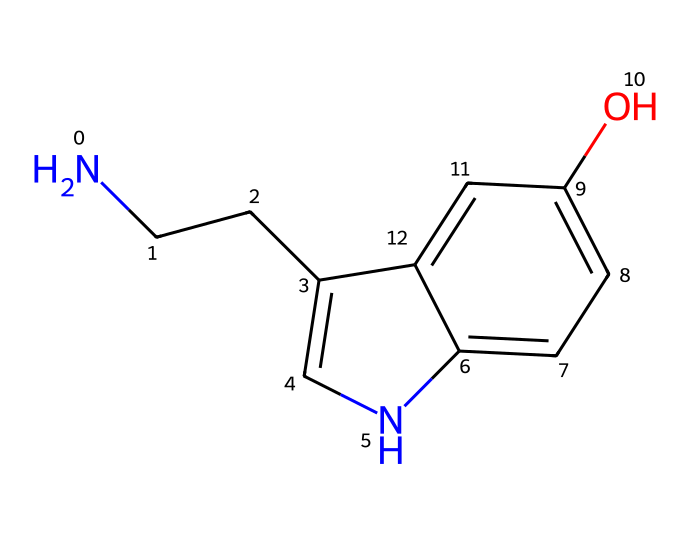How many carbon atoms are in the molecule? By examining the molecular structure represented by the SMILES notation, we can identify the carbon atoms present. The notation indicates there are six carbon atoms (c1, c2, the two CCC, and the others linked in the aromatic system).
Answer: six What is the molecular formula of this chemical? To determine the molecular formula, we count the types of atoms present: six carbon (C), seven hydrogen (H), one nitrogen (N), and one oxygen (O). This gives us the molecular formula C10H12N2O.
Answer: C10H12N2O How many nitrogen atoms are in serotonin? From the SMILES representation, we can locate the nitrogen atoms indicated by "N" within the structure. There is one nitrogen atom in the provided structure.
Answer: one What type of organic compound does serotonin belong to? The structure involves a bicyclic amine with an -OH group, characteristic of neurotransmitters. Given these features, serotonin is classified as an indole alkaloid.
Answer: indole alkaloid Which part of the molecule is responsible for its role in mood regulation? The entire structure of serotonin, especially the indole ring and the hydroxyl (OH) group, play crucial roles in its function as a neurotransmitter linked to mood regulation. Serotonin's structural attributes define its interaction with serotonin receptors.
Answer: the indole ring and the hydroxyl group What functional group is present in serotonin? In addition to the carbon and nitrogen atoms, serotonin contains a hydroxyl (-OH) group. This feature classifies it as a phenolic compound, integral to its chemical properties.
Answer: hydroxyl group What is the significance of the double bonds in this structure? The presence of double bonds in the aromatic ring allows for resonance, which contributes to the stability and reactivity of the serotonin molecule. The delocalization of electrons makes the structure more stable and allows for interaction with biological targets.
Answer: resonance and stability 